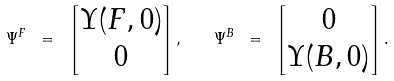<formula> <loc_0><loc_0><loc_500><loc_500>\Psi ^ { F } \ = \ \left [ \begin{matrix} \Upsilon ( F , 0 ) \\ 0 \end{matrix} \right ] , \quad \Psi ^ { B } \ = \ \left [ \begin{matrix} 0 \\ \Upsilon ( B , 0 ) \end{matrix} \right ] .</formula> 